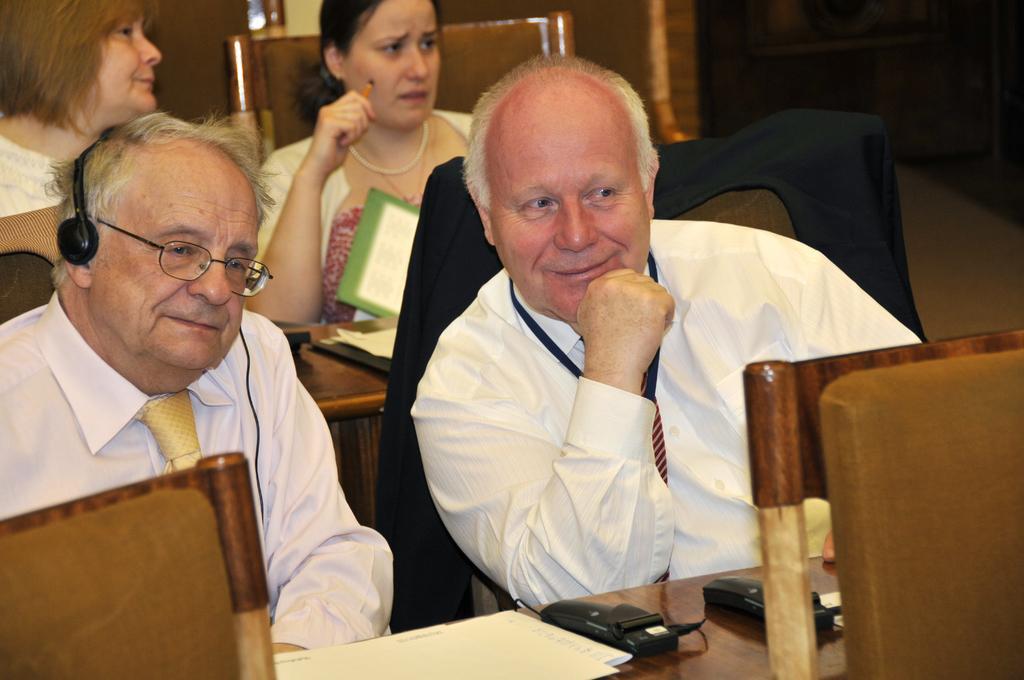Can you describe this image briefly? In this image there are group of people sitting in chair, and in table there are papers. 